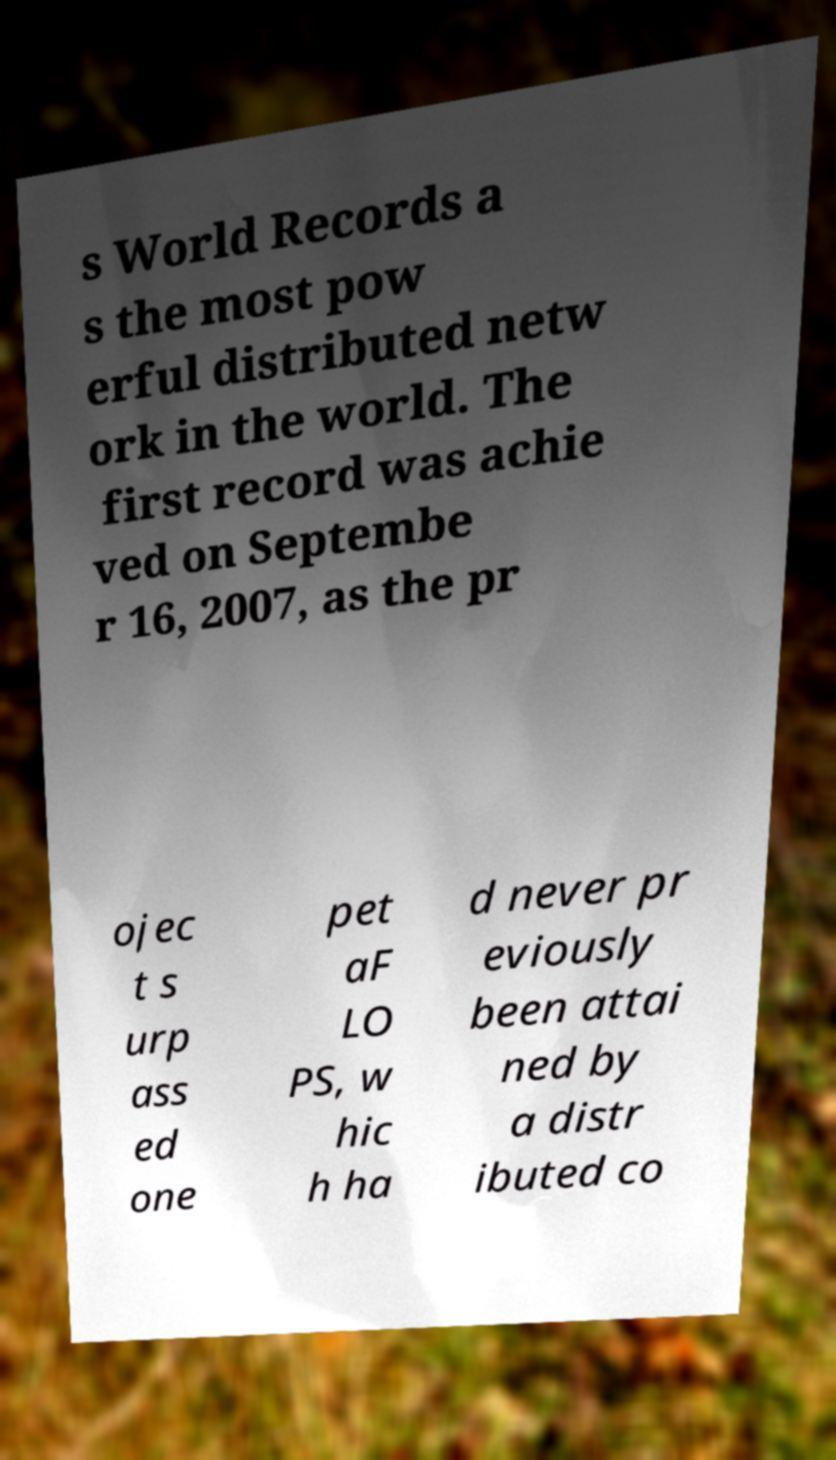For documentation purposes, I need the text within this image transcribed. Could you provide that? s World Records a s the most pow erful distributed netw ork in the world. The first record was achie ved on Septembe r 16, 2007, as the pr ojec t s urp ass ed one pet aF LO PS, w hic h ha d never pr eviously been attai ned by a distr ibuted co 